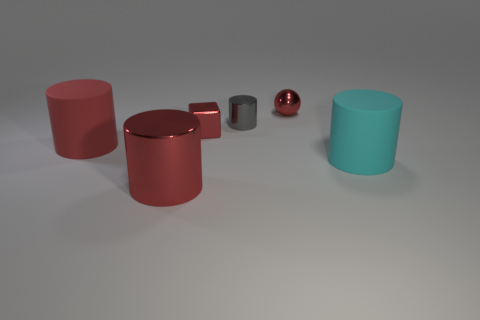There is a metal cube; is its color the same as the large object in front of the cyan thing?
Your response must be concise. Yes. The red metal thing that is both behind the large cyan thing and left of the red metal sphere has what shape?
Offer a very short reply. Cube. How many large cylinders are there?
Provide a short and direct response. 3. There is another large object that is the same color as the large metallic object; what shape is it?
Provide a succinct answer. Cylinder. What size is the other matte object that is the same shape as the cyan rubber thing?
Keep it short and to the point. Large. Is the shape of the tiny metallic object right of the tiny cylinder the same as  the large cyan rubber thing?
Offer a terse response. No. What color is the large rubber cylinder to the right of the red metal block?
Offer a terse response. Cyan. How many other objects are the same size as the gray cylinder?
Make the answer very short. 2. Are there an equal number of red metallic objects behind the small cylinder and large red rubber cylinders?
Provide a short and direct response. Yes. How many red objects have the same material as the cube?
Make the answer very short. 2. 